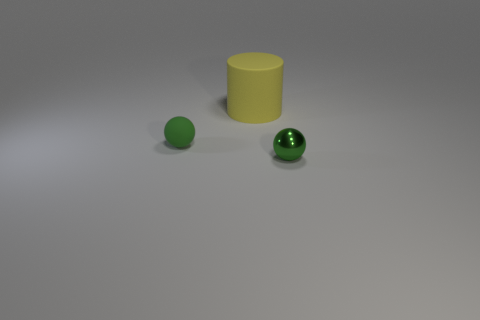Add 3 spheres. How many objects exist? 6 Subtract 1 cylinders. How many cylinders are left? 0 Subtract all balls. How many objects are left? 1 Add 2 tiny green matte objects. How many tiny green matte objects exist? 3 Subtract 0 brown cylinders. How many objects are left? 3 Subtract all brown cylinders. Subtract all blue cubes. How many cylinders are left? 1 Subtract all yellow balls. How many cyan cylinders are left? 0 Subtract all green things. Subtract all red cubes. How many objects are left? 1 Add 3 matte cylinders. How many matte cylinders are left? 4 